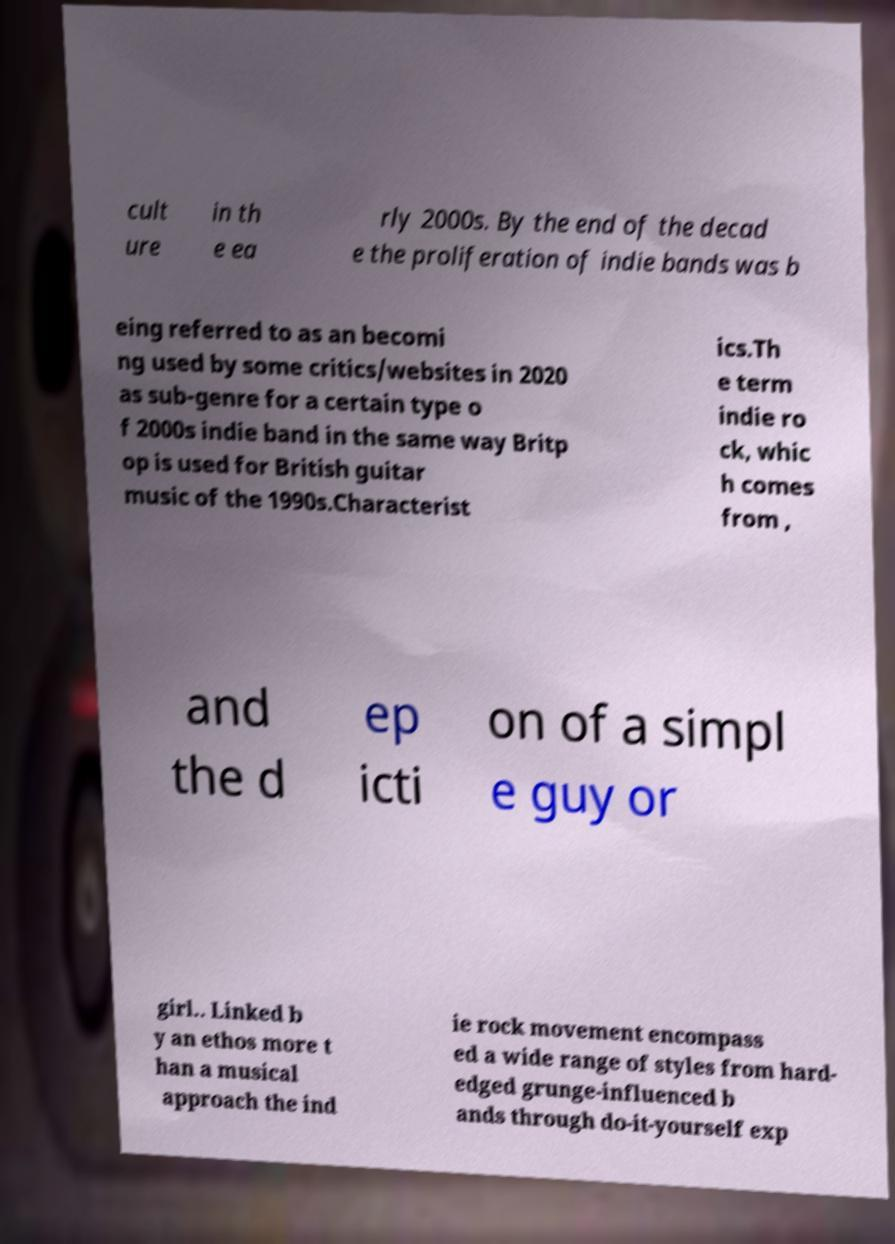Could you extract and type out the text from this image? cult ure in th e ea rly 2000s. By the end of the decad e the proliferation of indie bands was b eing referred to as an becomi ng used by some critics/websites in 2020 as sub-genre for a certain type o f 2000s indie band in the same way Britp op is used for British guitar music of the 1990s.Characterist ics.Th e term indie ro ck, whic h comes from , and the d ep icti on of a simpl e guy or girl.. Linked b y an ethos more t han a musical approach the ind ie rock movement encompass ed a wide range of styles from hard- edged grunge-influenced b ands through do-it-yourself exp 